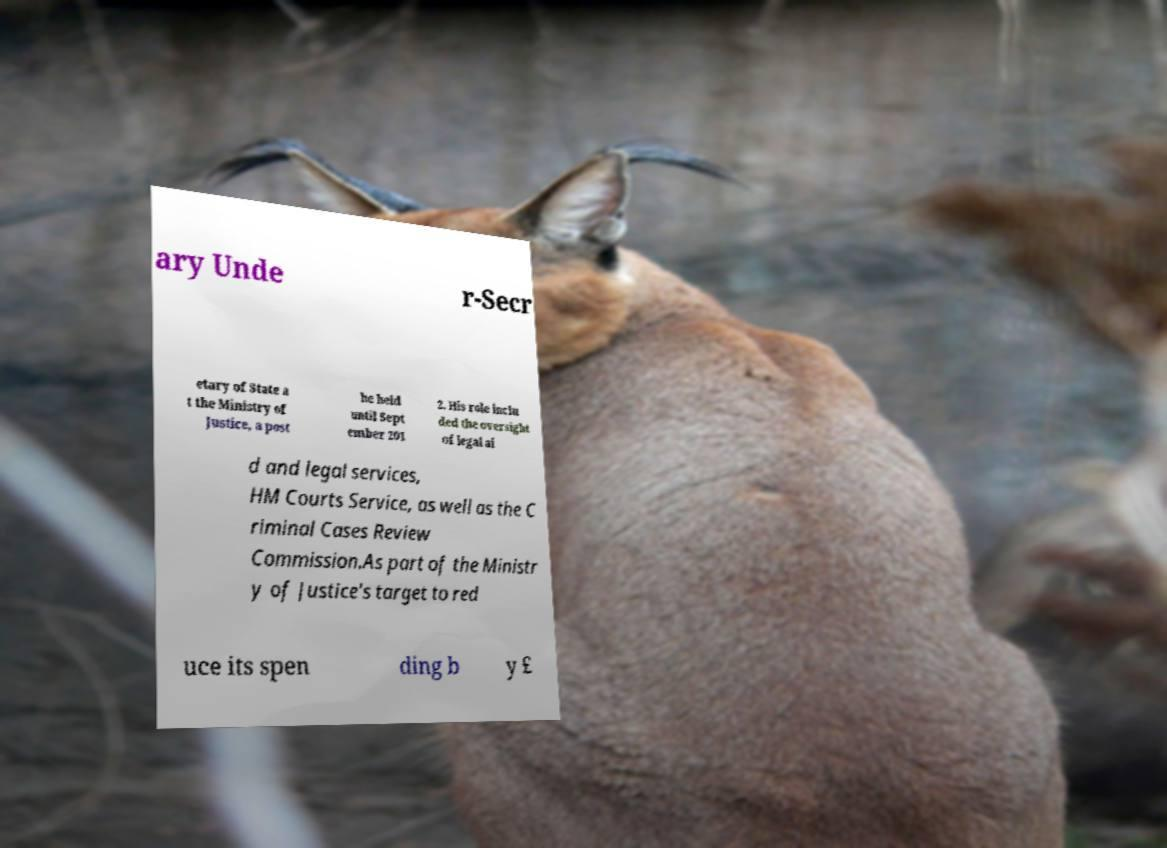There's text embedded in this image that I need extracted. Can you transcribe it verbatim? ary Unde r-Secr etary of State a t the Ministry of Justice, a post he held until Sept ember 201 2. His role inclu ded the oversight of legal ai d and legal services, HM Courts Service, as well as the C riminal Cases Review Commission.As part of the Ministr y of Justice's target to red uce its spen ding b y £ 